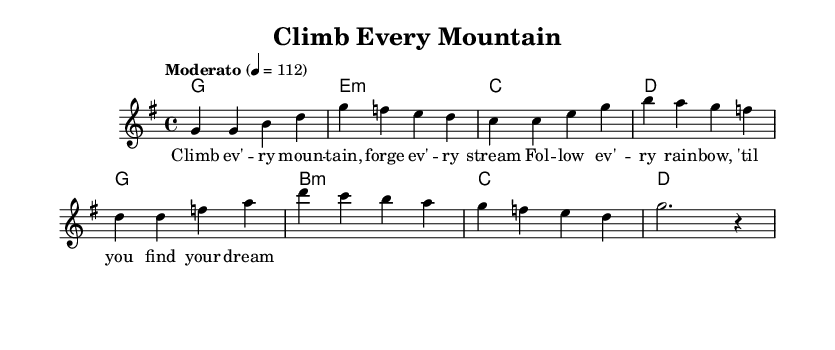What is the key signature of this music? The key signature is G major, which contains one sharp (F#) indicated at the beginning of the staff.
Answer: G major What is the time signature of this piece? The time signature is 4/4, shown at the beginning of the staff, meaning there are four beats in each measure.
Answer: 4/4 What is the tempo marking for this piece? The tempo marking indicates "Moderato," meaning moderately. Additionally, it specifies a metronome marking of quarter note equals 112 beats per minute.
Answer: Moderato How many measures are in the melody? The melody consists of 8 measures as seen in the arrangement, counted by the number of vertical lines separating the musical phrases.
Answer: 8 measures What is the last note of the melody? The last note of the melody is a rest, represented by "r" in the music notation, which indicates a pause instead of a sung note.
Answer: r How many chords are presented in the harmonies section? The harmonies section consists of four distinct chords, as indicated by the chord names aligned vertically with the measure lines.
Answer: 4 chords What is the thematic focus of the lyrics? The thematic focus of the lyrics is about perseverance and striving to achieve one’s dreams, as summarized by the phrases that encourage following rainbows and climbing mountains.
Answer: Perseverance 